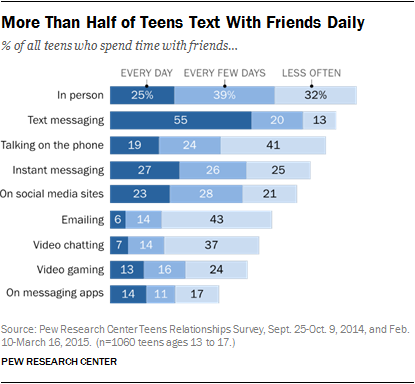List a handful of essential elements in this visual. According to a recent study, approximately 55% of teenagers report text messaging their friends on a daily basis. Approximately 84% of teenagers communicate with their peers via phone calls. 